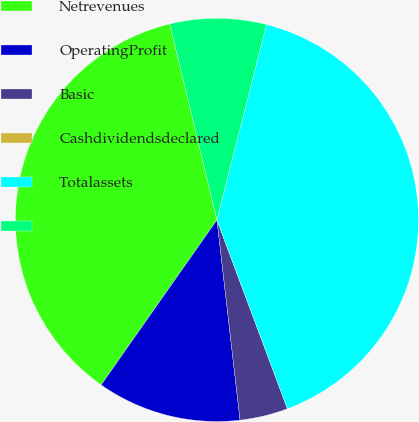Convert chart. <chart><loc_0><loc_0><loc_500><loc_500><pie_chart><fcel>Netrevenues<fcel>OperatingProfit<fcel>Basic<fcel>Cashdividendsdeclared<fcel>Totalassets<fcel>Unnamed: 5<nl><fcel>36.5%<fcel>11.57%<fcel>3.86%<fcel>0.0%<fcel>40.36%<fcel>7.71%<nl></chart> 